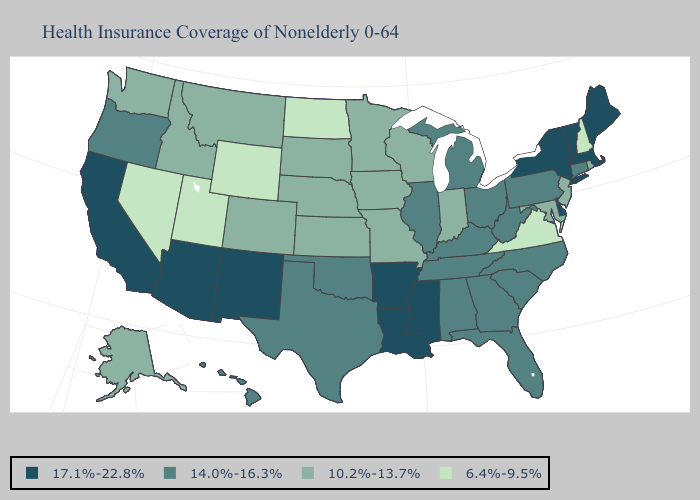Which states have the lowest value in the West?
Be succinct. Nevada, Utah, Wyoming. Name the states that have a value in the range 17.1%-22.8%?
Short answer required. Arizona, Arkansas, California, Delaware, Louisiana, Maine, Massachusetts, Mississippi, New Mexico, New York, Vermont. Name the states that have a value in the range 17.1%-22.8%?
Answer briefly. Arizona, Arkansas, California, Delaware, Louisiana, Maine, Massachusetts, Mississippi, New Mexico, New York, Vermont. Among the states that border Colorado , which have the lowest value?
Give a very brief answer. Utah, Wyoming. Name the states that have a value in the range 17.1%-22.8%?
Be succinct. Arizona, Arkansas, California, Delaware, Louisiana, Maine, Massachusetts, Mississippi, New Mexico, New York, Vermont. Does the first symbol in the legend represent the smallest category?
Quick response, please. No. What is the value of Georgia?
Concise answer only. 14.0%-16.3%. Does Florida have a lower value than Iowa?
Give a very brief answer. No. Name the states that have a value in the range 17.1%-22.8%?
Give a very brief answer. Arizona, Arkansas, California, Delaware, Louisiana, Maine, Massachusetts, Mississippi, New Mexico, New York, Vermont. Name the states that have a value in the range 10.2%-13.7%?
Answer briefly. Alaska, Colorado, Idaho, Indiana, Iowa, Kansas, Maryland, Minnesota, Missouri, Montana, Nebraska, New Jersey, Rhode Island, South Dakota, Washington, Wisconsin. What is the value of Mississippi?
Answer briefly. 17.1%-22.8%. What is the lowest value in the USA?
Write a very short answer. 6.4%-9.5%. Name the states that have a value in the range 14.0%-16.3%?
Write a very short answer. Alabama, Connecticut, Florida, Georgia, Hawaii, Illinois, Kentucky, Michigan, North Carolina, Ohio, Oklahoma, Oregon, Pennsylvania, South Carolina, Tennessee, Texas, West Virginia. Does California have the highest value in the USA?
Answer briefly. Yes. Which states hav the highest value in the South?
Keep it brief. Arkansas, Delaware, Louisiana, Mississippi. 